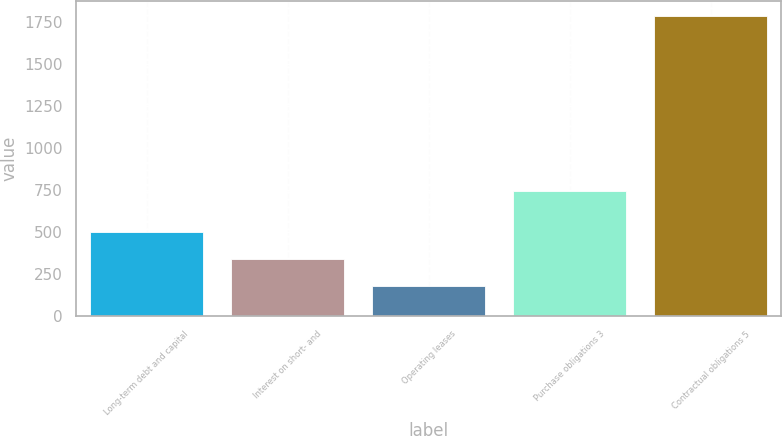Convert chart. <chart><loc_0><loc_0><loc_500><loc_500><bar_chart><fcel>Long-term debt and capital<fcel>Interest on short- and<fcel>Operating leases<fcel>Purchase obligations 3<fcel>Contractual obligations 5<nl><fcel>501.6<fcel>341.3<fcel>181<fcel>744<fcel>1784<nl></chart> 